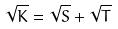<formula> <loc_0><loc_0><loc_500><loc_500>\sqrt { K } = \sqrt { S } + \sqrt { T }</formula> 